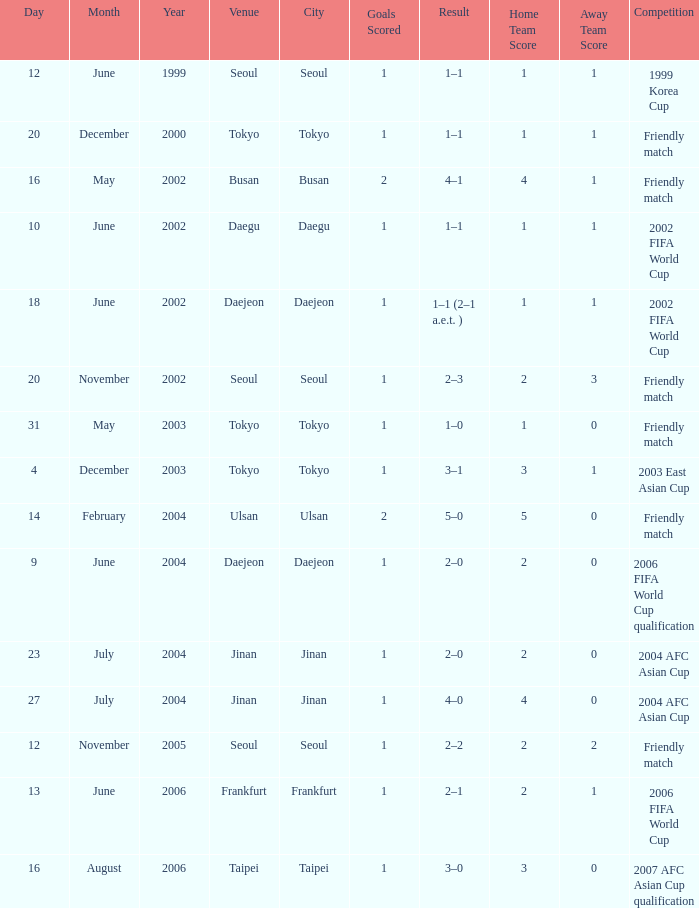What is the competition that occured on 27 July 2004? 2004 AFC Asian Cup. 